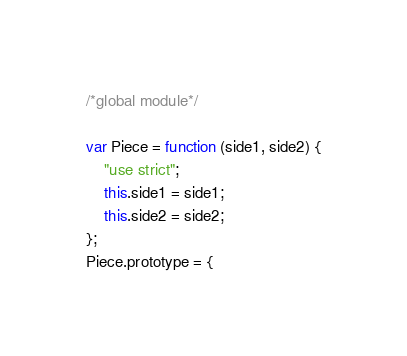<code> <loc_0><loc_0><loc_500><loc_500><_JavaScript_>/*global module*/

var Piece = function (side1, side2) {
    "use strict";
    this.side1 = side1;
    this.side2 = side2;
};
Piece.prototype = {</code> 